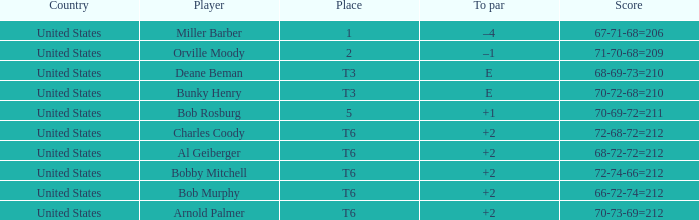Who is the player with a t6 place and a 72-68-72=212 score? Charles Coody. 